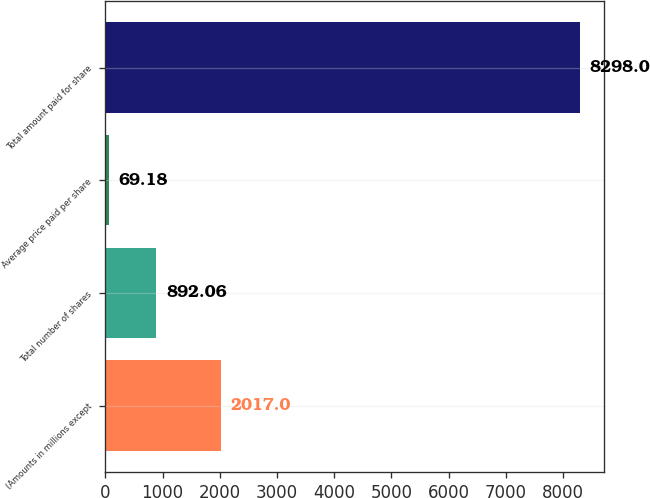Convert chart to OTSL. <chart><loc_0><loc_0><loc_500><loc_500><bar_chart><fcel>(Amounts in millions except<fcel>Total number of shares<fcel>Average price paid per share<fcel>Total amount paid for share<nl><fcel>2017<fcel>892.06<fcel>69.18<fcel>8298<nl></chart> 